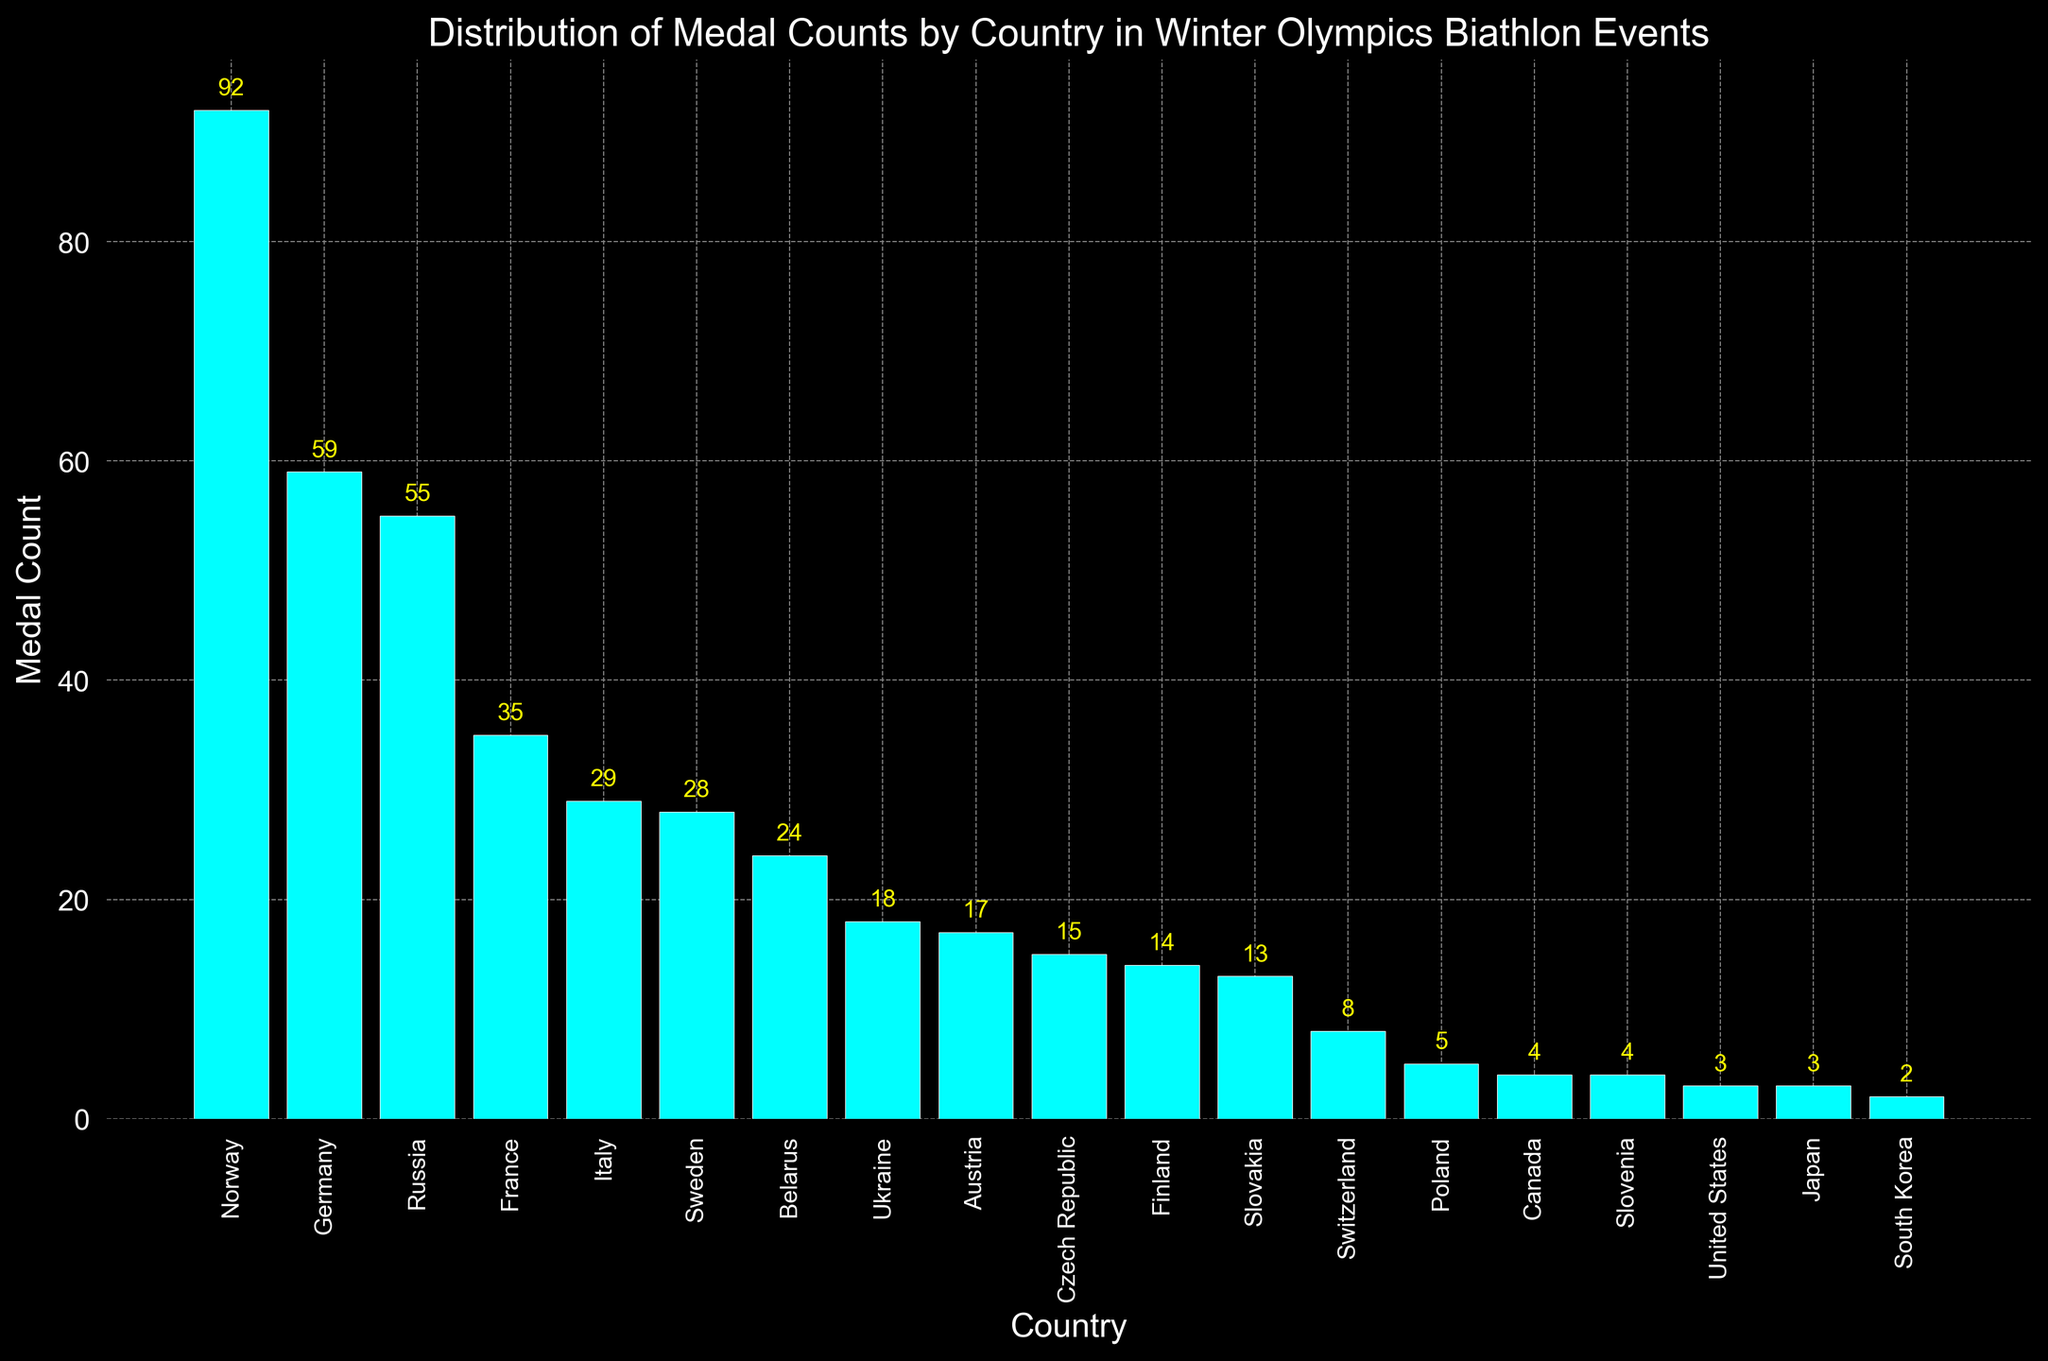Which country has the highest medal count? Observing the bar heights, Norway has the highest bar indicating the highest medal count of 92.
Answer: Norway How many more medals does Norway have compared to Germany? Norway has 92 medals, and Germany has 59. The difference is 92 - 59, which equals 33.
Answer: 33 What is the total medal count for France, Italy, and Sweden combined? Summing up the medal counts: France (35), Italy (29), and Sweden (28) gives 35 + 29 + 28 = 92.
Answer: 92 Which countries have a medal count less than 10? Observing the bar heights, countries with bars lower than 10 are Switzerland, Poland, Canada, Slovenia, United States, Japan, and South Korea.
Answer: Switzerland, Poland, Canada, Slovenia, United States, Japan, South Korea Which country is ranked third in terms of medal counts? By looking at the descending order of bars, Russia is positioned third with 55 medals.
Answer: Russia How many countries have a medal count greater than or equal to 20? Counting the bars with heights 20 or above, they are Norway, Germany, Russia, France, Italy, Sweden, and Belarus. There are 7 such countries.
Answer: 7 What is the median medal count of all the countries shown? Listing the medal counts in ascending order, the median is the 10th value in 19 sorted values: {2, 3, 3, 4, 4, 5, 8, 13, 14, 15, 17, 18, 24, 28, 29, 35, 55, 59, 92}, which is 15 (Czech Republic).
Answer: 15 Which country has the fourth highest medal count and how many medals do they have? The fourth highest bar corresponds to France with 35 medals.
Answer: France, 35 How many more medals does Italy have compared to Ukraine? Italy has 29 medals and Ukraine has 18. The difference is 29 - 18 = 11.
Answer: 11 What is the average medal count for the top 5 countries? The top 5 countries (Norway, Germany, Russia, France, Italy) have counts: 92, 59, 55, 35, 29. The average is (92 + 59 + 55 + 35 + 29) / 5 = 270 / 5 = 54.
Answer: 54 